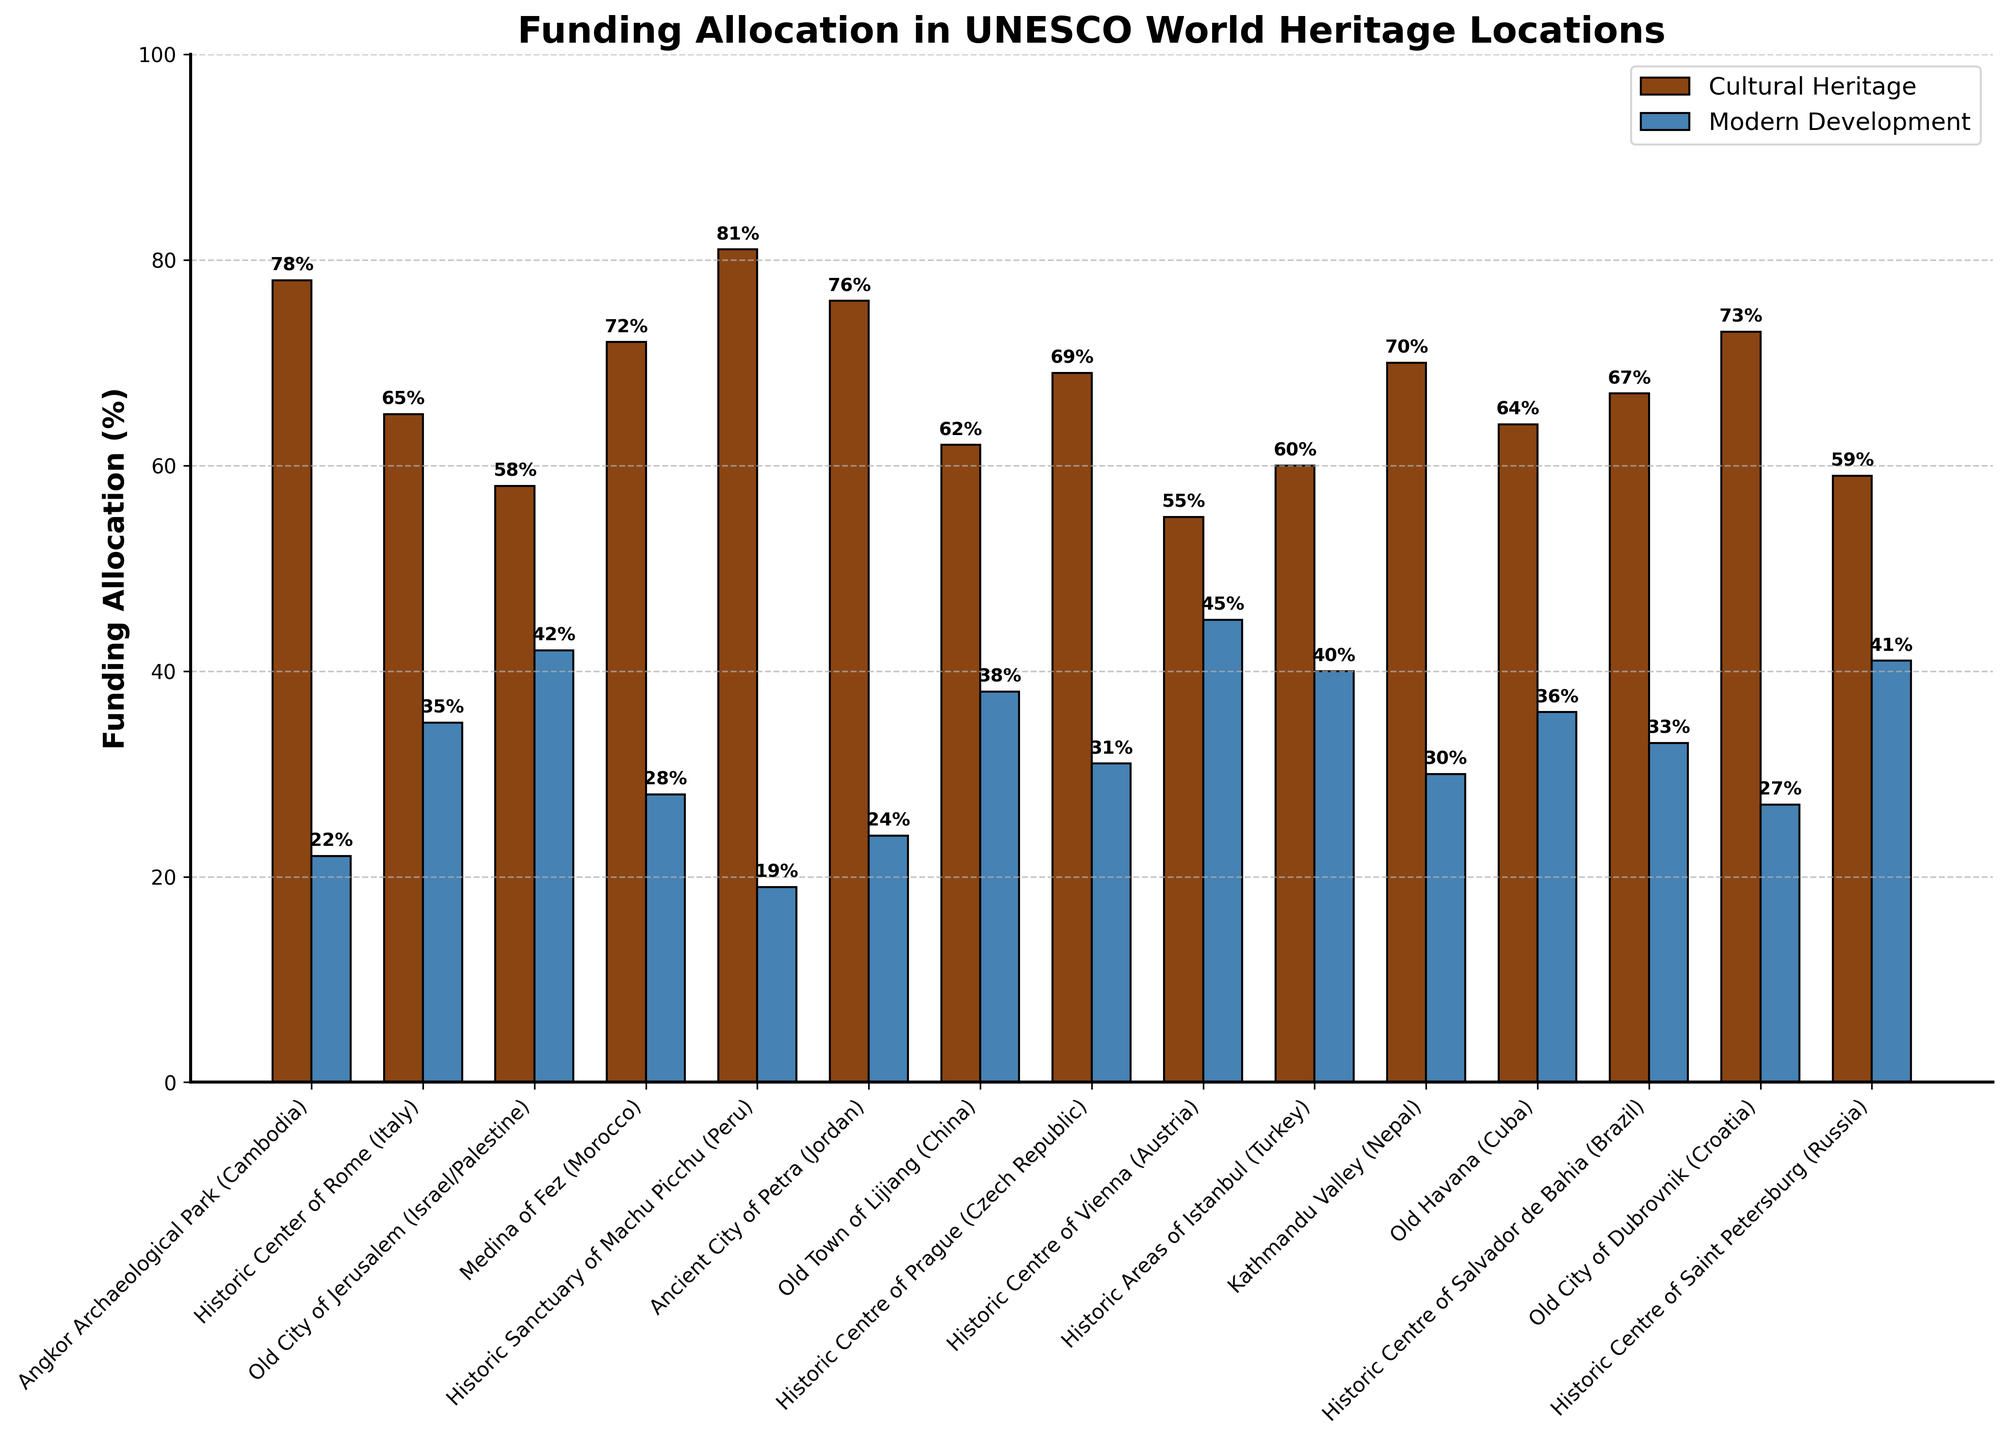Which UNESCO World Heritage location receives the highest percentage of funding for cultural heritage? By looking at the height of the bars for cultural heritage funding, the bars for "Historic Sanctuary of Machu Picchu (Peru)" are the tallest at 81%.
Answer: Historic Sanctuary of Machu Picchu (Peru) Which location receives the closest allocation between cultural heritage and modern development funding? By comparing the heights of each pair of bars, "Historic Centre of Vienna (Austria)" shows the closest allocation percentages, with 55% for cultural heritage and 45% for modern development.
Answer: Historic Centre of Vienna (Austria) What is the difference in funding allocation percentages between cultural heritage and modern development at the Old City of Jerusalem? The data shows 58% for cultural heritage and 42% for modern development. The difference is 58% - 42% = 16%.
Answer: 16% How many locations have cultural heritage funding of more than 70%? By visually scanning the heights of the bars, we see "Angkor Archaeological Park (Cambodia)", "Medina of Fez (Morocco)", "Historic Sanctuary of Machu Picchu (Peru)", "Ancient City of Petra (Jordan)", "Kathmandu Valley (Nepal)", and "Old City of Dubrovnik (Croatia)" have cultural heritage funding above 70%.
Answer: 6 What is the combined modern development funding percentage for Angkor Archaeological Park and Medina of Fez? The modern development funding for Angkor Archaeological Park is 22%, and for Medina of Fez, it is 28%. The sum is 22% + 28% = 50%.
Answer: 50% Which location receives the least percentage of funding for modern development projects? By examining the shortest bar for modern development funding, "Historic Sanctuary of Machu Picchu (Peru)" receives the least with 19%.
Answer: Historic Sanctuary of Machu Picchu (Peru) Is there any location where modern development funding exceeds cultural heritage funding? By comparing the heights of bars across all locations, none of the modern development bars exceed the cultural heritage bars.
Answer: No What is the average cultural heritage funding allocation across all locations? Sum the cultural heritage funding percentages (78 + 65 + 58 + 72 + 81 + 76 + 62 + 69 + 55 + 60 + 70 + 64 + 67 + 73 + 59) and divide by the number of locations (15). The sum is 1069%, and the average is 1069/15 = 71.27%.
Answer: 71.27% What is the funding difference between cultural heritage and modern development in the Historic Centre of Prague? The funding for cultural heritage is 69%, and for modern development, it is 31%. The difference is 69% - 31% = 38%.
Answer: 38% Which location has the highest combined total funding? The total funding for each location is always 100% since every pair sums to 100%. Therefore, the combined total funding is the same for every location.
Answer: Equal 